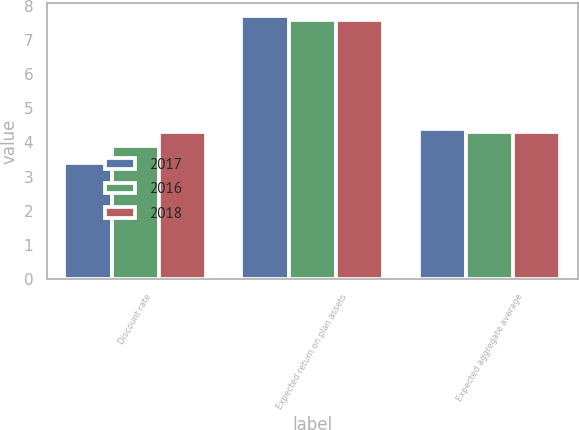Convert chart to OTSL. <chart><loc_0><loc_0><loc_500><loc_500><stacked_bar_chart><ecel><fcel>Discount rate<fcel>Expected return on plan assets<fcel>Expected aggregate average<nl><fcel>2017<fcel>3.4<fcel>7.7<fcel>4.4<nl><fcel>2016<fcel>3.9<fcel>7.6<fcel>4.3<nl><fcel>2018<fcel>4.3<fcel>7.6<fcel>4.3<nl></chart> 